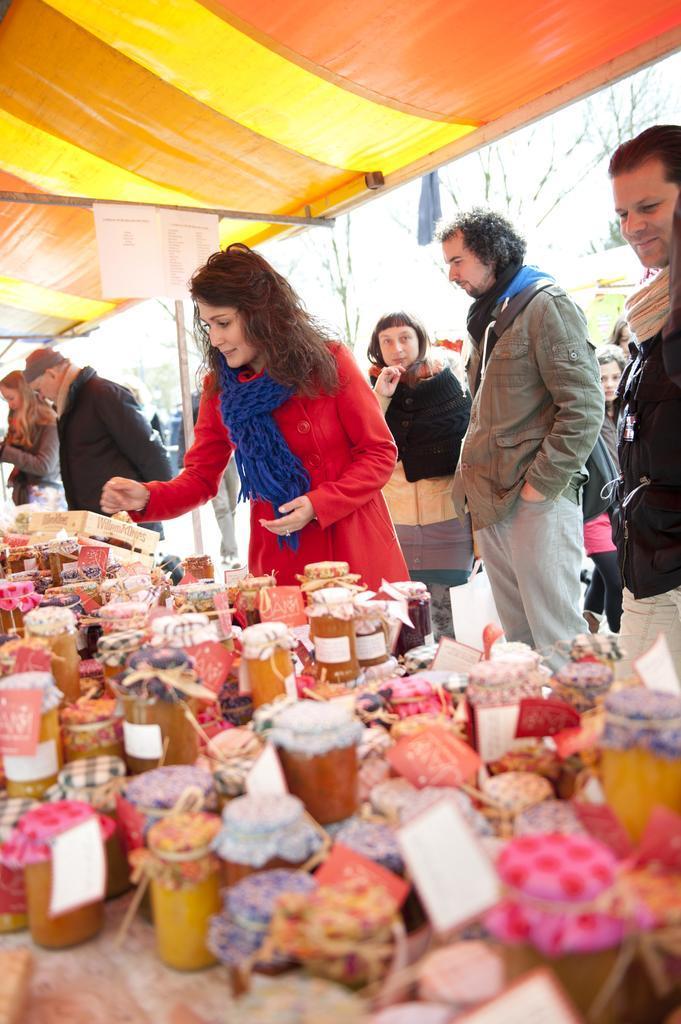How would you summarize this image in a sentence or two? In the foreground of the picture there is a table, on the table we can see lot of bottles and presents. In the middle of the picture there are people. At the top we can see tent. In the background there are trees. 